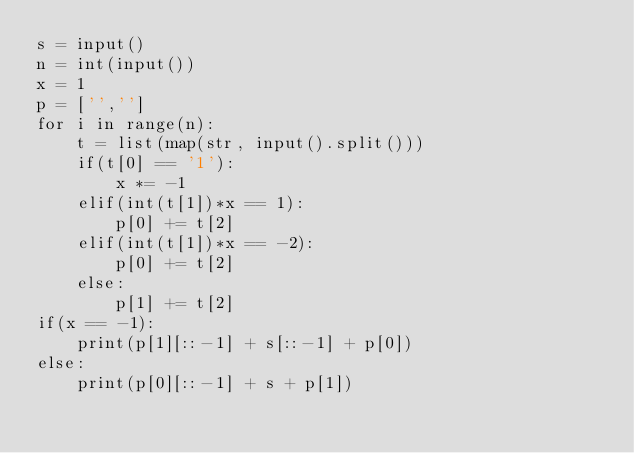<code> <loc_0><loc_0><loc_500><loc_500><_Python_>s = input()
n = int(input())
x = 1
p = ['','']
for i in range(n):
    t = list(map(str, input().split()))
    if(t[0] == '1'):
        x *= -1
    elif(int(t[1])*x == 1):
        p[0] += t[2]
    elif(int(t[1])*x == -2):
        p[0] += t[2]
    else:
        p[1] += t[2]
if(x == -1):
    print(p[1][::-1] + s[::-1] + p[0])
else:
    print(p[0][::-1] + s + p[1])</code> 